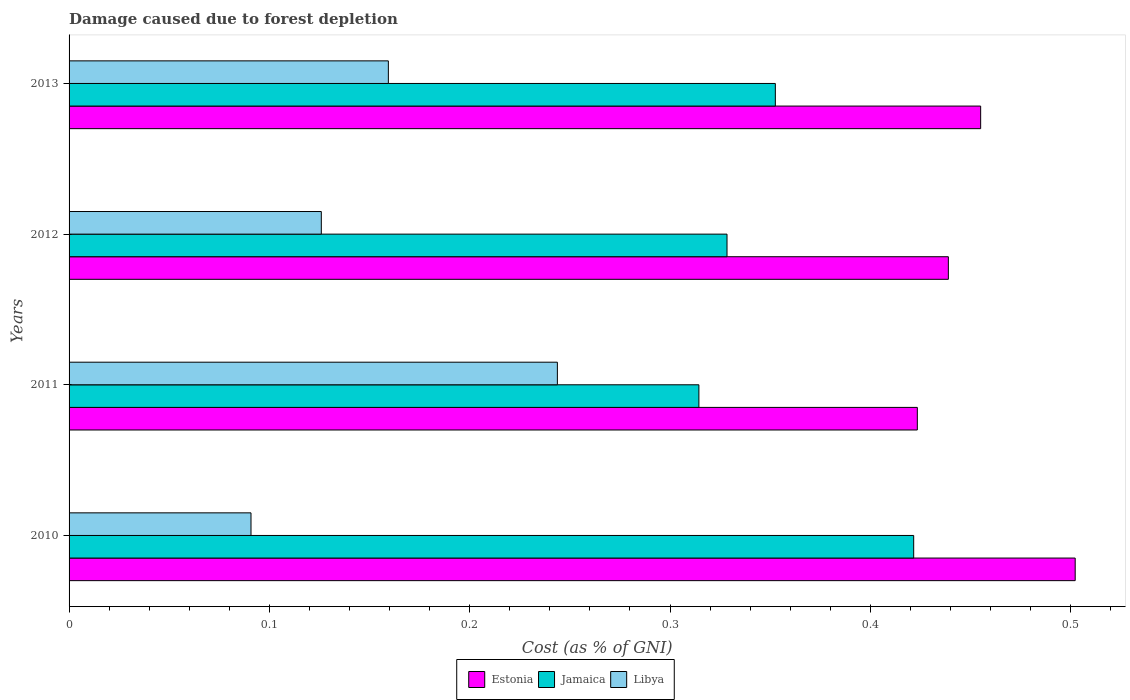How many groups of bars are there?
Provide a short and direct response. 4. Are the number of bars per tick equal to the number of legend labels?
Give a very brief answer. Yes. Are the number of bars on each tick of the Y-axis equal?
Ensure brevity in your answer.  Yes. How many bars are there on the 2nd tick from the top?
Offer a terse response. 3. In how many cases, is the number of bars for a given year not equal to the number of legend labels?
Offer a very short reply. 0. What is the cost of damage caused due to forest depletion in Jamaica in 2010?
Offer a very short reply. 0.42. Across all years, what is the maximum cost of damage caused due to forest depletion in Jamaica?
Your answer should be very brief. 0.42. Across all years, what is the minimum cost of damage caused due to forest depletion in Estonia?
Keep it short and to the point. 0.42. What is the total cost of damage caused due to forest depletion in Estonia in the graph?
Provide a succinct answer. 1.82. What is the difference between the cost of damage caused due to forest depletion in Libya in 2011 and that in 2013?
Offer a very short reply. 0.08. What is the difference between the cost of damage caused due to forest depletion in Estonia in 2011 and the cost of damage caused due to forest depletion in Libya in 2013?
Provide a succinct answer. 0.26. What is the average cost of damage caused due to forest depletion in Jamaica per year?
Your response must be concise. 0.35. In the year 2011, what is the difference between the cost of damage caused due to forest depletion in Estonia and cost of damage caused due to forest depletion in Libya?
Your answer should be compact. 0.18. What is the ratio of the cost of damage caused due to forest depletion in Estonia in 2012 to that in 2013?
Provide a short and direct response. 0.96. Is the cost of damage caused due to forest depletion in Jamaica in 2011 less than that in 2013?
Offer a terse response. Yes. Is the difference between the cost of damage caused due to forest depletion in Estonia in 2010 and 2011 greater than the difference between the cost of damage caused due to forest depletion in Libya in 2010 and 2011?
Provide a short and direct response. Yes. What is the difference between the highest and the second highest cost of damage caused due to forest depletion in Libya?
Keep it short and to the point. 0.08. What is the difference between the highest and the lowest cost of damage caused due to forest depletion in Jamaica?
Offer a terse response. 0.11. In how many years, is the cost of damage caused due to forest depletion in Jamaica greater than the average cost of damage caused due to forest depletion in Jamaica taken over all years?
Offer a terse response. 1. What does the 3rd bar from the top in 2013 represents?
Provide a short and direct response. Estonia. What does the 1st bar from the bottom in 2010 represents?
Ensure brevity in your answer.  Estonia. Is it the case that in every year, the sum of the cost of damage caused due to forest depletion in Estonia and cost of damage caused due to forest depletion in Libya is greater than the cost of damage caused due to forest depletion in Jamaica?
Offer a very short reply. Yes. What is the difference between two consecutive major ticks on the X-axis?
Offer a terse response. 0.1. Does the graph contain any zero values?
Your response must be concise. No. Does the graph contain grids?
Keep it short and to the point. No. How are the legend labels stacked?
Your answer should be compact. Horizontal. What is the title of the graph?
Ensure brevity in your answer.  Damage caused due to forest depletion. What is the label or title of the X-axis?
Provide a succinct answer. Cost (as % of GNI). What is the label or title of the Y-axis?
Your answer should be very brief. Years. What is the Cost (as % of GNI) in Estonia in 2010?
Offer a very short reply. 0.5. What is the Cost (as % of GNI) of Jamaica in 2010?
Ensure brevity in your answer.  0.42. What is the Cost (as % of GNI) of Libya in 2010?
Your response must be concise. 0.09. What is the Cost (as % of GNI) in Estonia in 2011?
Offer a very short reply. 0.42. What is the Cost (as % of GNI) in Jamaica in 2011?
Make the answer very short. 0.31. What is the Cost (as % of GNI) in Libya in 2011?
Offer a terse response. 0.24. What is the Cost (as % of GNI) of Estonia in 2012?
Ensure brevity in your answer.  0.44. What is the Cost (as % of GNI) in Jamaica in 2012?
Keep it short and to the point. 0.33. What is the Cost (as % of GNI) of Libya in 2012?
Your response must be concise. 0.13. What is the Cost (as % of GNI) in Estonia in 2013?
Your response must be concise. 0.46. What is the Cost (as % of GNI) of Jamaica in 2013?
Provide a short and direct response. 0.35. What is the Cost (as % of GNI) of Libya in 2013?
Offer a very short reply. 0.16. Across all years, what is the maximum Cost (as % of GNI) in Estonia?
Provide a short and direct response. 0.5. Across all years, what is the maximum Cost (as % of GNI) of Jamaica?
Offer a terse response. 0.42. Across all years, what is the maximum Cost (as % of GNI) in Libya?
Offer a terse response. 0.24. Across all years, what is the minimum Cost (as % of GNI) in Estonia?
Your answer should be very brief. 0.42. Across all years, what is the minimum Cost (as % of GNI) in Jamaica?
Ensure brevity in your answer.  0.31. Across all years, what is the minimum Cost (as % of GNI) in Libya?
Provide a succinct answer. 0.09. What is the total Cost (as % of GNI) of Estonia in the graph?
Provide a succinct answer. 1.82. What is the total Cost (as % of GNI) of Jamaica in the graph?
Your response must be concise. 1.42. What is the total Cost (as % of GNI) of Libya in the graph?
Your answer should be very brief. 0.62. What is the difference between the Cost (as % of GNI) in Estonia in 2010 and that in 2011?
Offer a very short reply. 0.08. What is the difference between the Cost (as % of GNI) of Jamaica in 2010 and that in 2011?
Give a very brief answer. 0.11. What is the difference between the Cost (as % of GNI) in Libya in 2010 and that in 2011?
Provide a succinct answer. -0.15. What is the difference between the Cost (as % of GNI) in Estonia in 2010 and that in 2012?
Provide a succinct answer. 0.06. What is the difference between the Cost (as % of GNI) of Jamaica in 2010 and that in 2012?
Your answer should be very brief. 0.09. What is the difference between the Cost (as % of GNI) in Libya in 2010 and that in 2012?
Your answer should be very brief. -0.04. What is the difference between the Cost (as % of GNI) of Estonia in 2010 and that in 2013?
Keep it short and to the point. 0.05. What is the difference between the Cost (as % of GNI) of Jamaica in 2010 and that in 2013?
Offer a very short reply. 0.07. What is the difference between the Cost (as % of GNI) in Libya in 2010 and that in 2013?
Your response must be concise. -0.07. What is the difference between the Cost (as % of GNI) of Estonia in 2011 and that in 2012?
Provide a succinct answer. -0.02. What is the difference between the Cost (as % of GNI) of Jamaica in 2011 and that in 2012?
Offer a terse response. -0.01. What is the difference between the Cost (as % of GNI) of Libya in 2011 and that in 2012?
Provide a short and direct response. 0.12. What is the difference between the Cost (as % of GNI) in Estonia in 2011 and that in 2013?
Provide a short and direct response. -0.03. What is the difference between the Cost (as % of GNI) of Jamaica in 2011 and that in 2013?
Your response must be concise. -0.04. What is the difference between the Cost (as % of GNI) of Libya in 2011 and that in 2013?
Make the answer very short. 0.08. What is the difference between the Cost (as % of GNI) in Estonia in 2012 and that in 2013?
Your answer should be compact. -0.02. What is the difference between the Cost (as % of GNI) in Jamaica in 2012 and that in 2013?
Your answer should be compact. -0.02. What is the difference between the Cost (as % of GNI) of Libya in 2012 and that in 2013?
Make the answer very short. -0.03. What is the difference between the Cost (as % of GNI) of Estonia in 2010 and the Cost (as % of GNI) of Jamaica in 2011?
Your answer should be very brief. 0.19. What is the difference between the Cost (as % of GNI) in Estonia in 2010 and the Cost (as % of GNI) in Libya in 2011?
Provide a succinct answer. 0.26. What is the difference between the Cost (as % of GNI) in Jamaica in 2010 and the Cost (as % of GNI) in Libya in 2011?
Give a very brief answer. 0.18. What is the difference between the Cost (as % of GNI) in Estonia in 2010 and the Cost (as % of GNI) in Jamaica in 2012?
Your answer should be compact. 0.17. What is the difference between the Cost (as % of GNI) in Estonia in 2010 and the Cost (as % of GNI) in Libya in 2012?
Your response must be concise. 0.38. What is the difference between the Cost (as % of GNI) in Jamaica in 2010 and the Cost (as % of GNI) in Libya in 2012?
Keep it short and to the point. 0.3. What is the difference between the Cost (as % of GNI) in Estonia in 2010 and the Cost (as % of GNI) in Jamaica in 2013?
Your answer should be compact. 0.15. What is the difference between the Cost (as % of GNI) of Estonia in 2010 and the Cost (as % of GNI) of Libya in 2013?
Keep it short and to the point. 0.34. What is the difference between the Cost (as % of GNI) of Jamaica in 2010 and the Cost (as % of GNI) of Libya in 2013?
Provide a short and direct response. 0.26. What is the difference between the Cost (as % of GNI) in Estonia in 2011 and the Cost (as % of GNI) in Jamaica in 2012?
Provide a succinct answer. 0.1. What is the difference between the Cost (as % of GNI) of Estonia in 2011 and the Cost (as % of GNI) of Libya in 2012?
Ensure brevity in your answer.  0.3. What is the difference between the Cost (as % of GNI) in Jamaica in 2011 and the Cost (as % of GNI) in Libya in 2012?
Your answer should be compact. 0.19. What is the difference between the Cost (as % of GNI) of Estonia in 2011 and the Cost (as % of GNI) of Jamaica in 2013?
Provide a succinct answer. 0.07. What is the difference between the Cost (as % of GNI) of Estonia in 2011 and the Cost (as % of GNI) of Libya in 2013?
Make the answer very short. 0.26. What is the difference between the Cost (as % of GNI) of Jamaica in 2011 and the Cost (as % of GNI) of Libya in 2013?
Ensure brevity in your answer.  0.15. What is the difference between the Cost (as % of GNI) in Estonia in 2012 and the Cost (as % of GNI) in Jamaica in 2013?
Provide a succinct answer. 0.09. What is the difference between the Cost (as % of GNI) of Estonia in 2012 and the Cost (as % of GNI) of Libya in 2013?
Your response must be concise. 0.28. What is the difference between the Cost (as % of GNI) of Jamaica in 2012 and the Cost (as % of GNI) of Libya in 2013?
Ensure brevity in your answer.  0.17. What is the average Cost (as % of GNI) in Estonia per year?
Offer a terse response. 0.46. What is the average Cost (as % of GNI) of Jamaica per year?
Offer a terse response. 0.35. What is the average Cost (as % of GNI) of Libya per year?
Offer a very short reply. 0.15. In the year 2010, what is the difference between the Cost (as % of GNI) in Estonia and Cost (as % of GNI) in Jamaica?
Your answer should be compact. 0.08. In the year 2010, what is the difference between the Cost (as % of GNI) in Estonia and Cost (as % of GNI) in Libya?
Offer a very short reply. 0.41. In the year 2010, what is the difference between the Cost (as % of GNI) in Jamaica and Cost (as % of GNI) in Libya?
Ensure brevity in your answer.  0.33. In the year 2011, what is the difference between the Cost (as % of GNI) of Estonia and Cost (as % of GNI) of Jamaica?
Make the answer very short. 0.11. In the year 2011, what is the difference between the Cost (as % of GNI) of Estonia and Cost (as % of GNI) of Libya?
Keep it short and to the point. 0.18. In the year 2011, what is the difference between the Cost (as % of GNI) of Jamaica and Cost (as % of GNI) of Libya?
Provide a short and direct response. 0.07. In the year 2012, what is the difference between the Cost (as % of GNI) in Estonia and Cost (as % of GNI) in Jamaica?
Ensure brevity in your answer.  0.11. In the year 2012, what is the difference between the Cost (as % of GNI) in Estonia and Cost (as % of GNI) in Libya?
Offer a very short reply. 0.31. In the year 2012, what is the difference between the Cost (as % of GNI) of Jamaica and Cost (as % of GNI) of Libya?
Your answer should be compact. 0.2. In the year 2013, what is the difference between the Cost (as % of GNI) in Estonia and Cost (as % of GNI) in Jamaica?
Provide a short and direct response. 0.1. In the year 2013, what is the difference between the Cost (as % of GNI) in Estonia and Cost (as % of GNI) in Libya?
Give a very brief answer. 0.3. In the year 2013, what is the difference between the Cost (as % of GNI) of Jamaica and Cost (as % of GNI) of Libya?
Provide a succinct answer. 0.19. What is the ratio of the Cost (as % of GNI) of Estonia in 2010 to that in 2011?
Your response must be concise. 1.19. What is the ratio of the Cost (as % of GNI) in Jamaica in 2010 to that in 2011?
Offer a terse response. 1.34. What is the ratio of the Cost (as % of GNI) of Libya in 2010 to that in 2011?
Offer a terse response. 0.37. What is the ratio of the Cost (as % of GNI) of Estonia in 2010 to that in 2012?
Provide a succinct answer. 1.14. What is the ratio of the Cost (as % of GNI) of Jamaica in 2010 to that in 2012?
Make the answer very short. 1.28. What is the ratio of the Cost (as % of GNI) in Libya in 2010 to that in 2012?
Give a very brief answer. 0.72. What is the ratio of the Cost (as % of GNI) in Estonia in 2010 to that in 2013?
Provide a short and direct response. 1.1. What is the ratio of the Cost (as % of GNI) in Jamaica in 2010 to that in 2013?
Ensure brevity in your answer.  1.2. What is the ratio of the Cost (as % of GNI) of Libya in 2010 to that in 2013?
Your answer should be compact. 0.57. What is the ratio of the Cost (as % of GNI) of Estonia in 2011 to that in 2012?
Provide a short and direct response. 0.96. What is the ratio of the Cost (as % of GNI) in Jamaica in 2011 to that in 2012?
Give a very brief answer. 0.96. What is the ratio of the Cost (as % of GNI) of Libya in 2011 to that in 2012?
Give a very brief answer. 1.94. What is the ratio of the Cost (as % of GNI) in Estonia in 2011 to that in 2013?
Make the answer very short. 0.93. What is the ratio of the Cost (as % of GNI) in Jamaica in 2011 to that in 2013?
Offer a very short reply. 0.89. What is the ratio of the Cost (as % of GNI) in Libya in 2011 to that in 2013?
Make the answer very short. 1.53. What is the ratio of the Cost (as % of GNI) in Estonia in 2012 to that in 2013?
Provide a short and direct response. 0.96. What is the ratio of the Cost (as % of GNI) in Jamaica in 2012 to that in 2013?
Your response must be concise. 0.93. What is the ratio of the Cost (as % of GNI) in Libya in 2012 to that in 2013?
Provide a short and direct response. 0.79. What is the difference between the highest and the second highest Cost (as % of GNI) in Estonia?
Your response must be concise. 0.05. What is the difference between the highest and the second highest Cost (as % of GNI) in Jamaica?
Your answer should be very brief. 0.07. What is the difference between the highest and the second highest Cost (as % of GNI) of Libya?
Provide a short and direct response. 0.08. What is the difference between the highest and the lowest Cost (as % of GNI) in Estonia?
Ensure brevity in your answer.  0.08. What is the difference between the highest and the lowest Cost (as % of GNI) of Jamaica?
Provide a short and direct response. 0.11. What is the difference between the highest and the lowest Cost (as % of GNI) in Libya?
Ensure brevity in your answer.  0.15. 